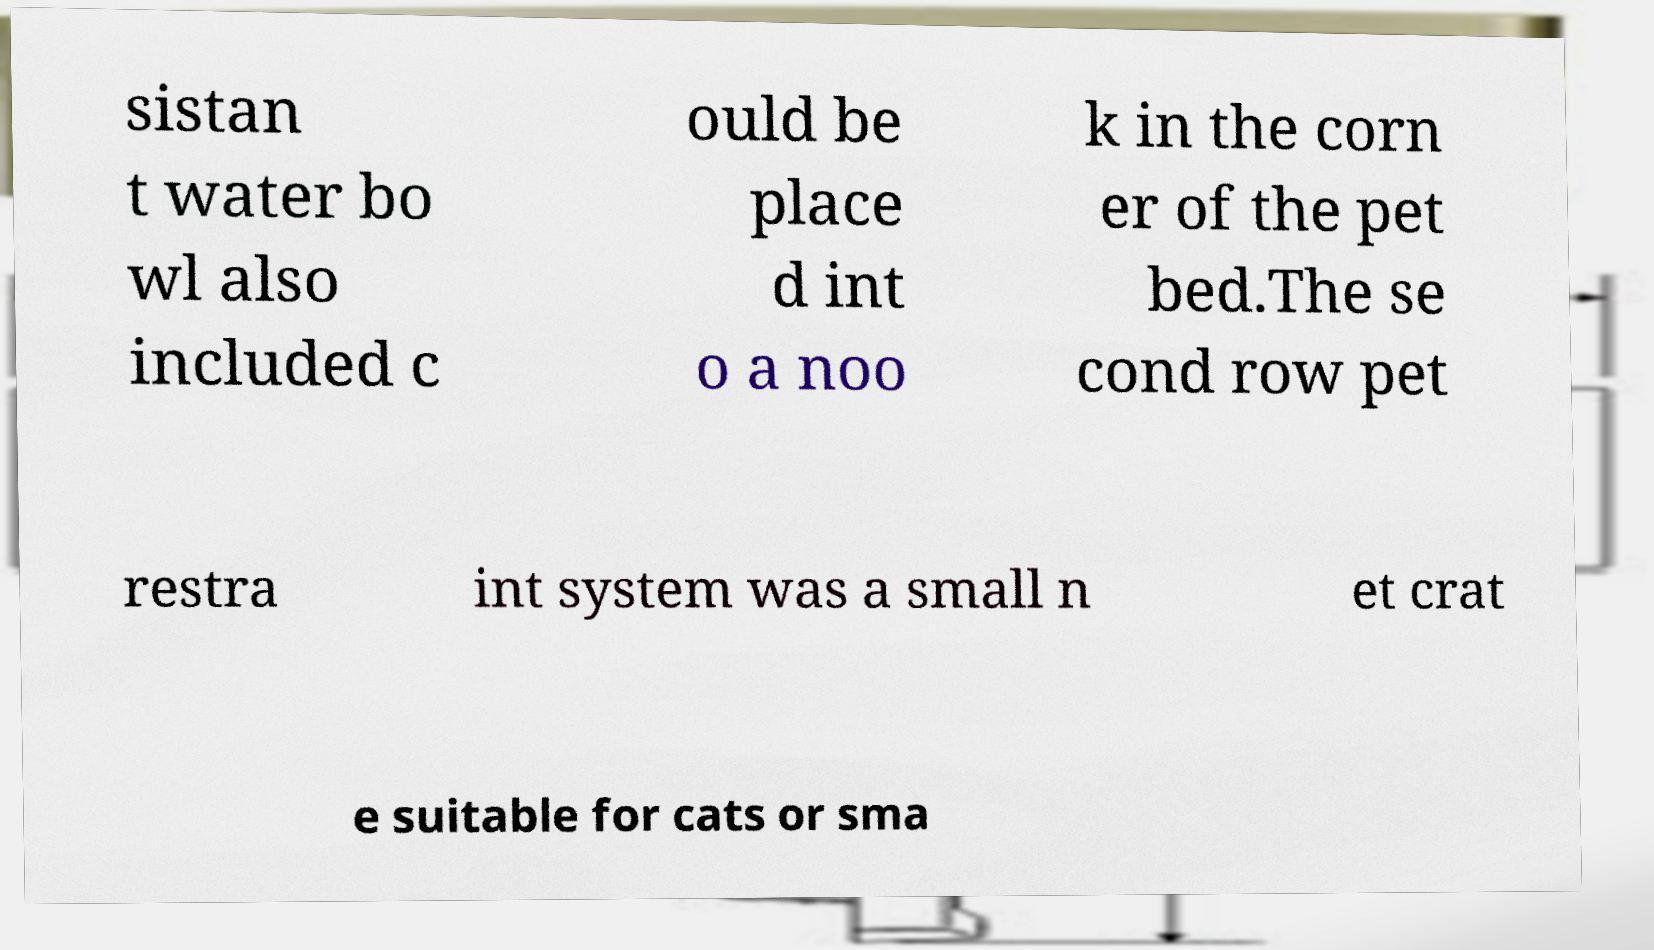For documentation purposes, I need the text within this image transcribed. Could you provide that? sistan t water bo wl also included c ould be place d int o a noo k in the corn er of the pet bed.The se cond row pet restra int system was a small n et crat e suitable for cats or sma 